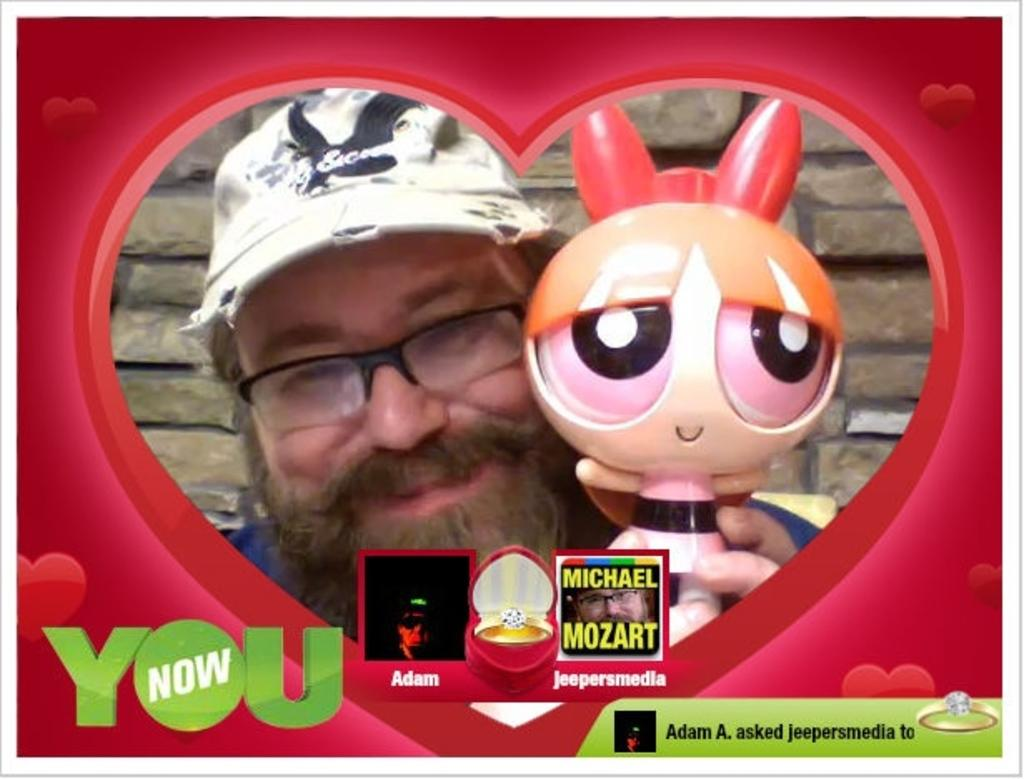What shape is the image edited into? The image is edited in a heart shape. Who is the main subject in the image? There is a man in the center of the image. What accessories is the man wearing? The man is wearing a cap, spectacles, and a shirt. What is the man holding in the image? The man is holding a doll. Where is the ring located in the image? There is a ring in the bottom right corner of the image. What type of government is depicted in the image? There is no depiction of a government in the image; it features a man holding a doll in a heart-shaped frame. Are there any trains visible in the image? No, there are no trains present in the image. 